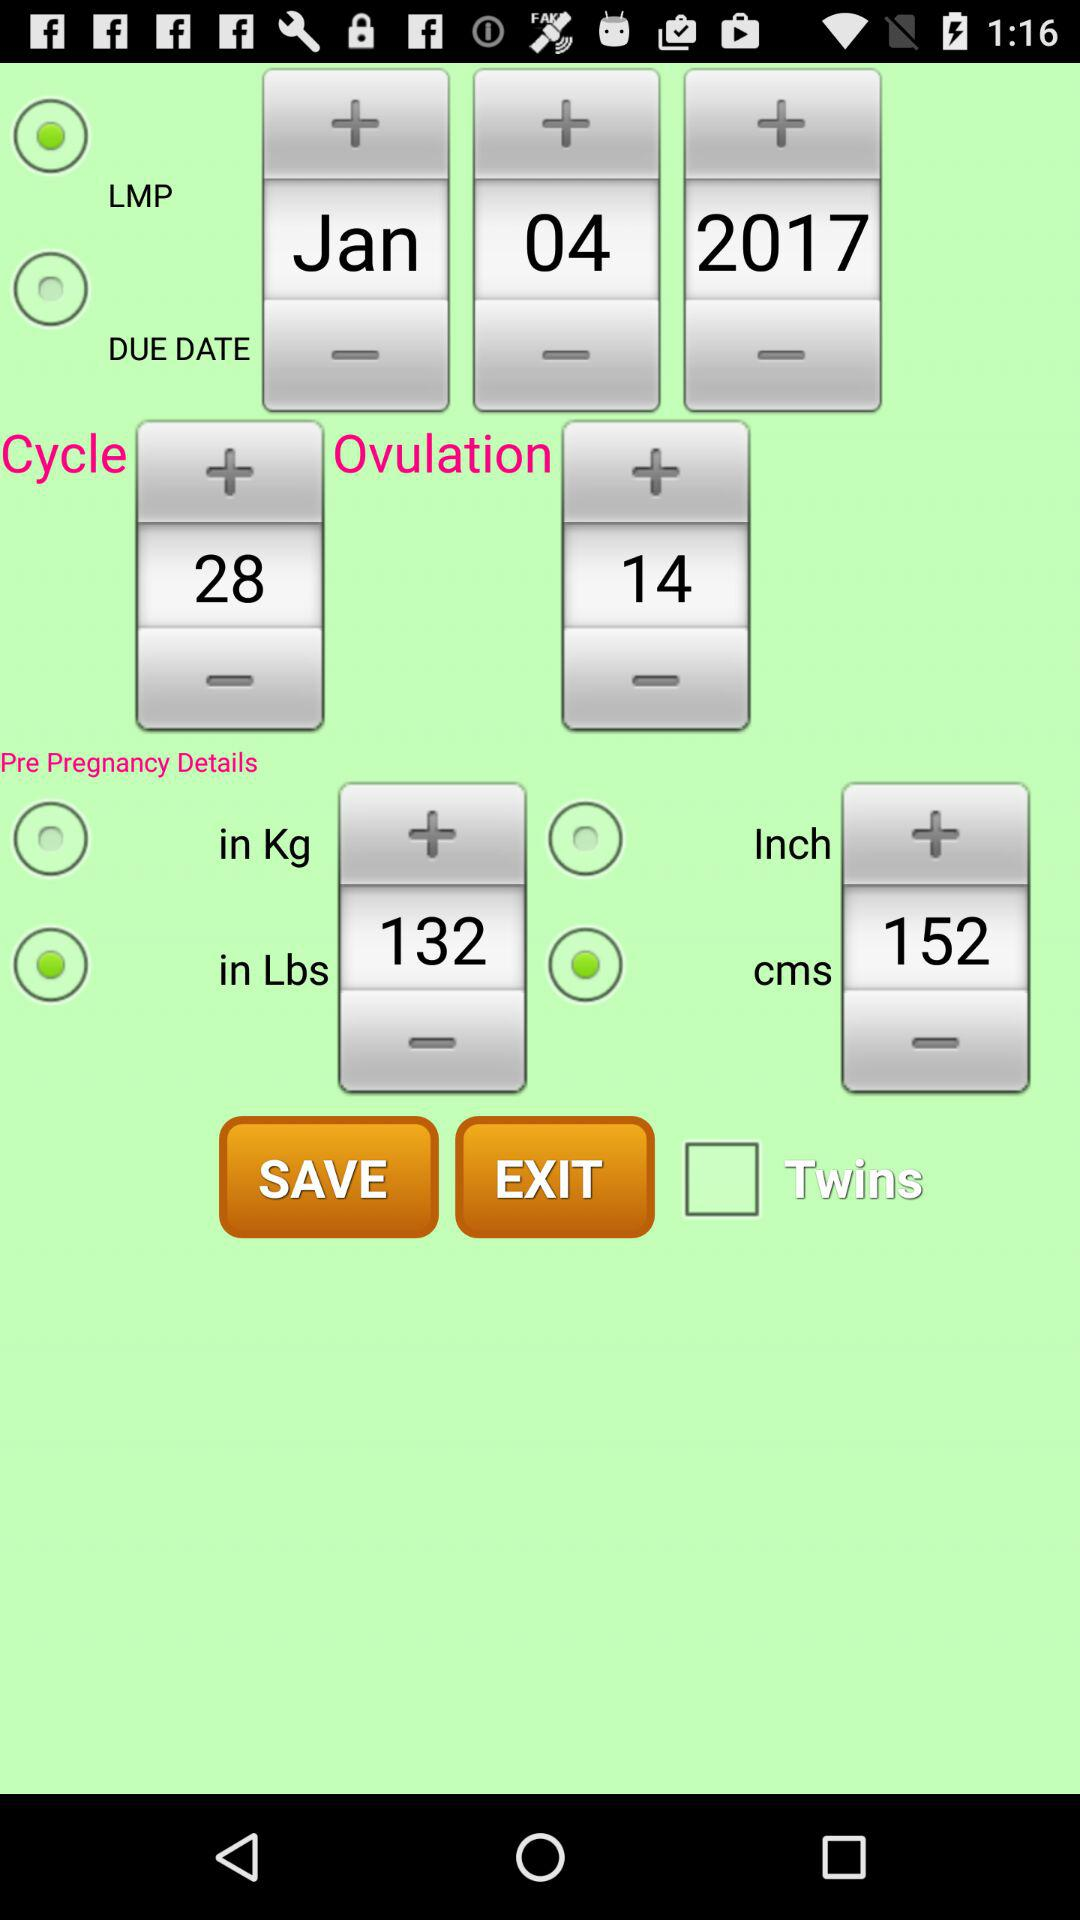Is “Twins” checked or unchecked?
Answer the question using a single word or phrase. "Twins" is unchecked. 